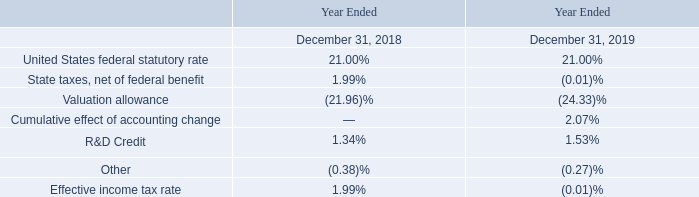Effective Income Tax Rate
A reconciliation of the United States federal statutory income tax rate to our effective income tax rate is as follows:
In 2019 and 2018 we had pre-tax losses of $19,573 and $25,403, respectively, which are available for carry forward to offset future taxable income. We made determinations to provide full valuation allowances for our net deferred tax assets at the end of 2019 and 2018, including NOL carryforwards generated during the years, based on our evaluation of positive and negative evidence, including our history of operating losses and the uncertainty of generating future taxable income that would enable us to realize our deferred tax.
What were the pre-tax losses in 2019? $19,573. Why are pre-tax losses made available for carrying forward? To offset future taxable income. What was the R&D Credit in 2019? 1.53%. What was the 2019 percentage change in pre-tax losses?
Answer scale should be: percent. (19,573 - 25,403)/25,403 
Answer: -22.95. What was the change in the United States federal statutory rate between 2018 and 2019?
Answer scale should be: percent. 21.00 - 21.00 
Answer: 0. Which year has a higher amount of pre-tax losses? 25,403 > 19,573
Answer: 2018. 